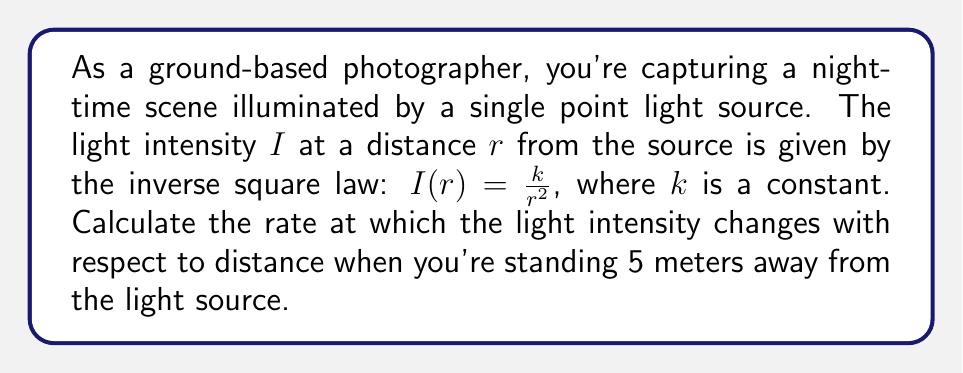What is the answer to this math problem? To solve this problem, we need to find the derivative of the light intensity function with respect to distance and then evaluate it at the given distance.

1) The light intensity function is given by:

   $$I(r) = \frac{k}{r^2}$$

2) To find the rate of change of intensity with respect to distance, we need to differentiate $I(r)$ with respect to $r$:

   $$\frac{dI}{dr} = \frac{d}{dr}\left(\frac{k}{r^2}\right)$$

3) Using the power rule of differentiation:

   $$\frac{dI}{dr} = k \cdot \frac{d}{dr}\left(r^{-2}\right) = k \cdot (-2)r^{-3} = -\frac{2k}{r^3}$$

4) This gives us the general formula for the rate of change of intensity with respect to distance.

5) Now, we need to evaluate this at $r = 5$ meters:

   $$\left.\frac{dI}{dr}\right|_{r=5} = -\frac{2k}{5^3} = -\frac{2k}{125}$$

6) The negative sign indicates that the intensity decreases as the distance increases.

7) Note that we can't simplify this further without knowing the value of $k$, which depends on the specific light source.
Answer: The rate of change of light intensity with respect to distance at 5 meters from the source is $-\frac{2k}{125}$ units of intensity per meter, where $k$ is the constant in the original intensity function. 